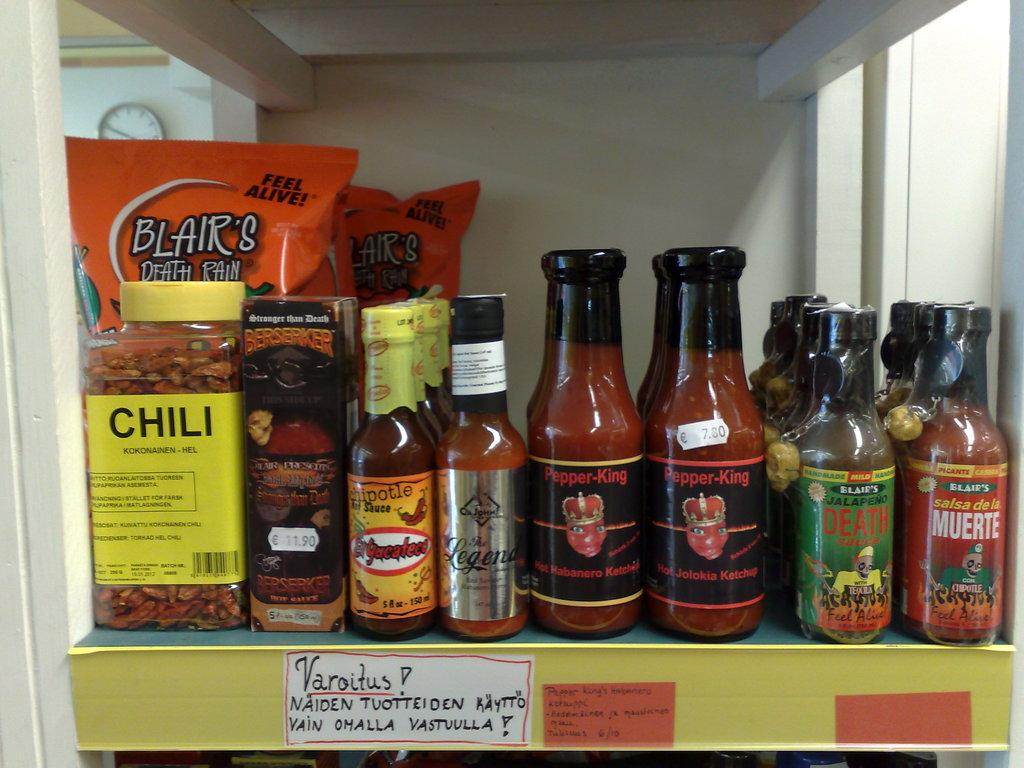<image>
Summarize the visual content of the image. Jar of chili and bottle of chipotle hot sauce on a rack. 